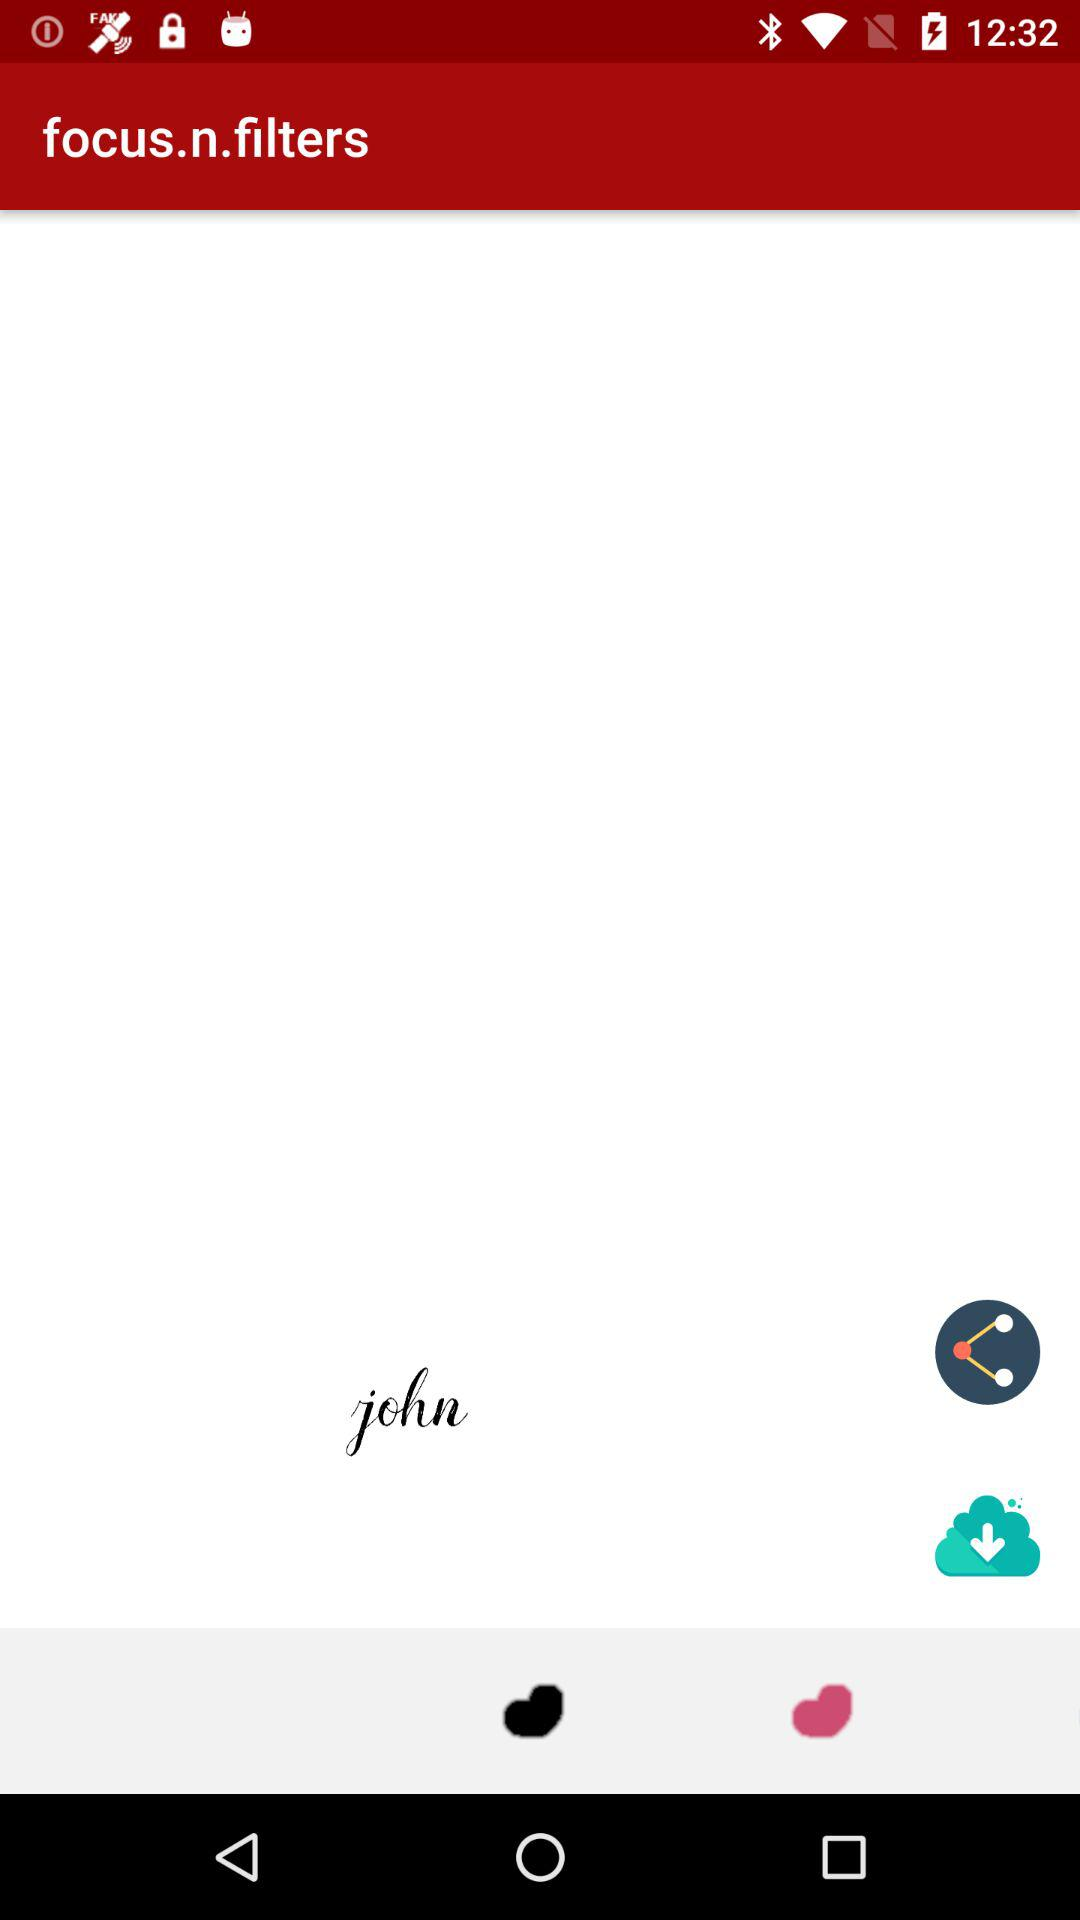What is the application name? The application name is "focus.n.filters". 